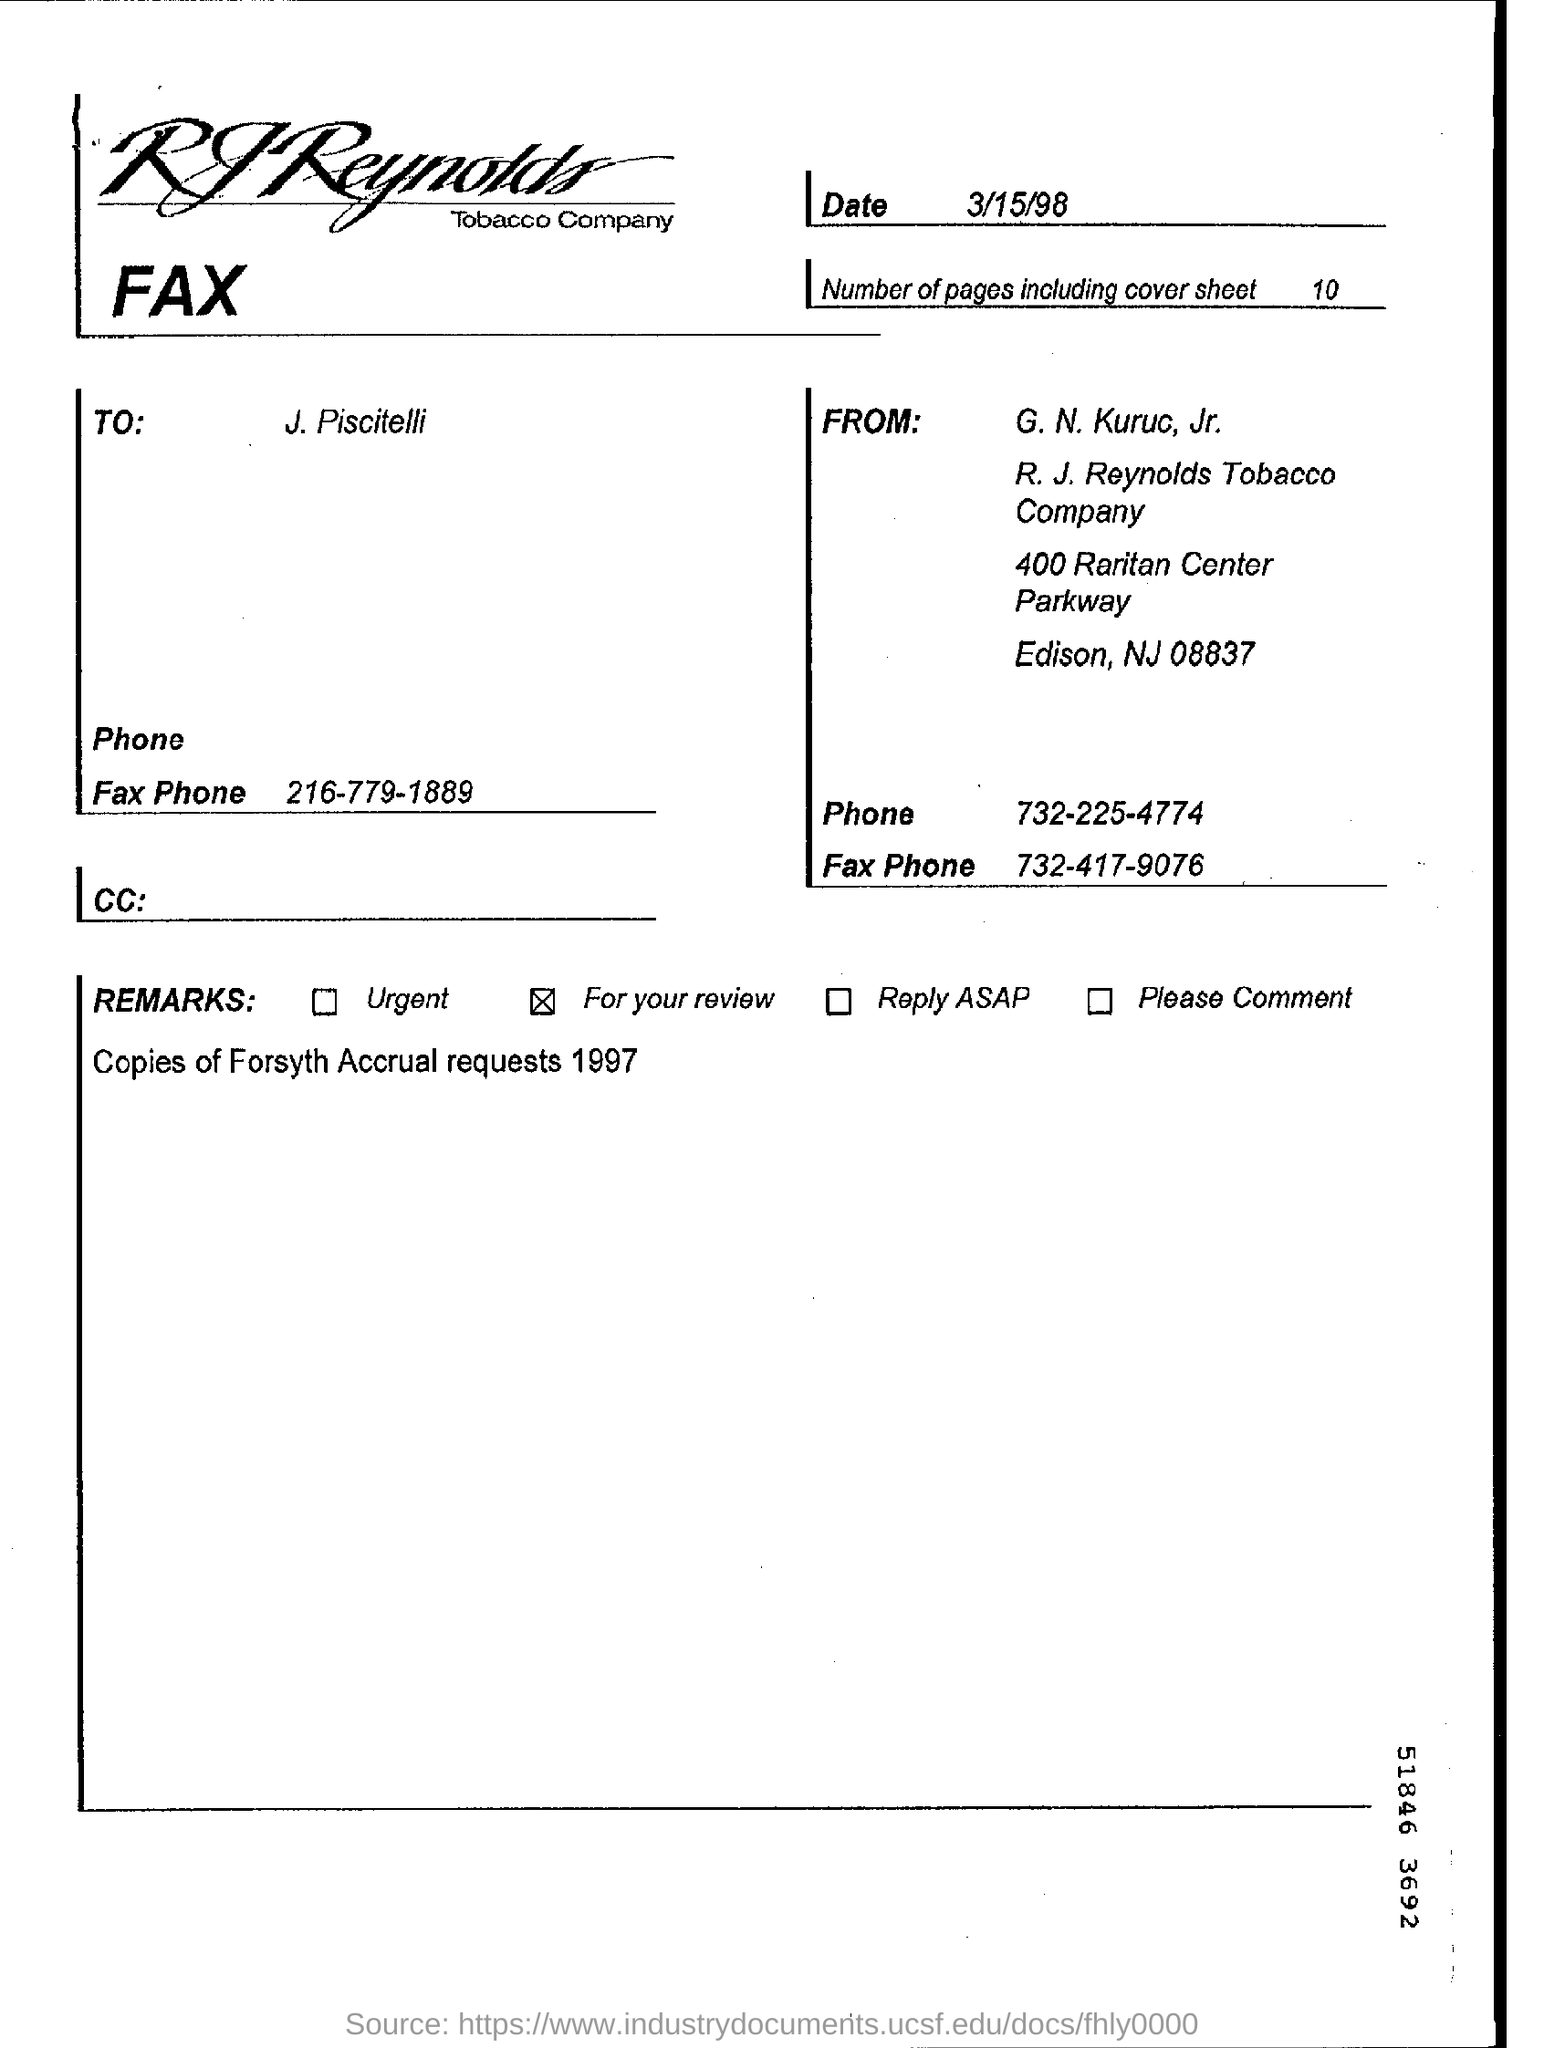Specify some key components in this picture. I faxed 10 sheets. The document was faxed by G. N. Kuruc, Jr. I have reviewed the remarks in the field and have noted that the selection is currently set to 'In'. The document was faxed on March 15, 1998. The zip code mentioned in the from address is 08837... 